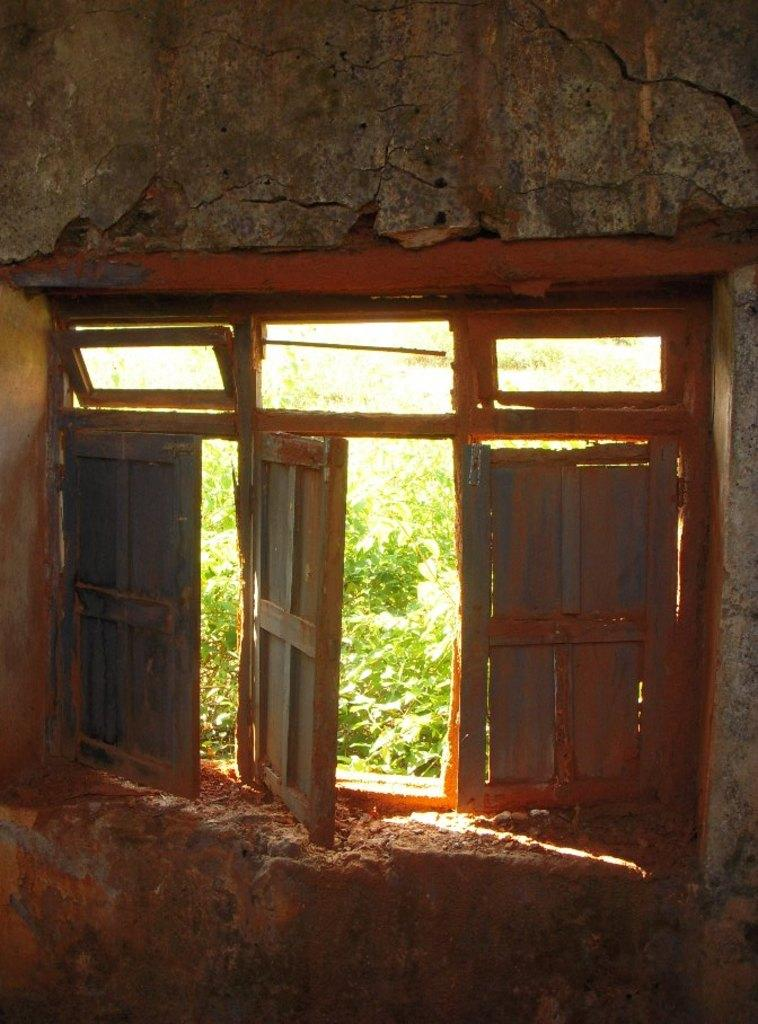What is a prominent feature of the wall in the image? There is a window in the wall in the image. What can be seen through the window? Plants are visible outside the window. How is the window connected to the wall? The window is part of the wall. What type of creature can be seen making an error on the wall in the image? There is no creature present in the image, and no errors are visible on the wall. 